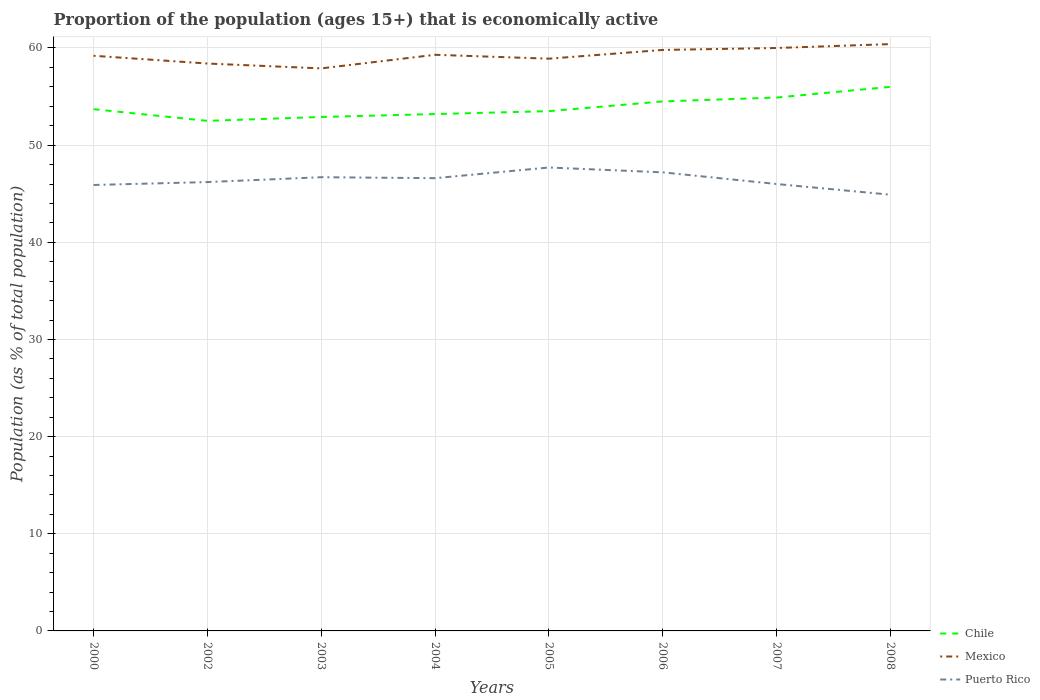How many different coloured lines are there?
Provide a succinct answer. 3. Across all years, what is the maximum proportion of the population that is economically active in Puerto Rico?
Make the answer very short. 44.9. What is the total proportion of the population that is economically active in Puerto Rico in the graph?
Ensure brevity in your answer.  0.6. What is the difference between the highest and the second highest proportion of the population that is economically active in Puerto Rico?
Make the answer very short. 2.8. What is the difference between the highest and the lowest proportion of the population that is economically active in Mexico?
Give a very brief answer. 4. Is the proportion of the population that is economically active in Mexico strictly greater than the proportion of the population that is economically active in Chile over the years?
Offer a terse response. No. How many years are there in the graph?
Your answer should be compact. 8. Does the graph contain any zero values?
Give a very brief answer. No. Does the graph contain grids?
Your response must be concise. Yes. How are the legend labels stacked?
Keep it short and to the point. Vertical. What is the title of the graph?
Ensure brevity in your answer.  Proportion of the population (ages 15+) that is economically active. Does "Niger" appear as one of the legend labels in the graph?
Your answer should be very brief. No. What is the label or title of the X-axis?
Offer a terse response. Years. What is the label or title of the Y-axis?
Make the answer very short. Population (as % of total population). What is the Population (as % of total population) of Chile in 2000?
Keep it short and to the point. 53.7. What is the Population (as % of total population) of Mexico in 2000?
Give a very brief answer. 59.2. What is the Population (as % of total population) of Puerto Rico in 2000?
Give a very brief answer. 45.9. What is the Population (as % of total population) of Chile in 2002?
Your answer should be compact. 52.5. What is the Population (as % of total population) in Mexico in 2002?
Ensure brevity in your answer.  58.4. What is the Population (as % of total population) in Puerto Rico in 2002?
Offer a terse response. 46.2. What is the Population (as % of total population) of Chile in 2003?
Your response must be concise. 52.9. What is the Population (as % of total population) of Mexico in 2003?
Keep it short and to the point. 57.9. What is the Population (as % of total population) in Puerto Rico in 2003?
Provide a succinct answer. 46.7. What is the Population (as % of total population) in Chile in 2004?
Keep it short and to the point. 53.2. What is the Population (as % of total population) of Mexico in 2004?
Your response must be concise. 59.3. What is the Population (as % of total population) of Puerto Rico in 2004?
Offer a terse response. 46.6. What is the Population (as % of total population) of Chile in 2005?
Your answer should be compact. 53.5. What is the Population (as % of total population) of Mexico in 2005?
Keep it short and to the point. 58.9. What is the Population (as % of total population) of Puerto Rico in 2005?
Keep it short and to the point. 47.7. What is the Population (as % of total population) in Chile in 2006?
Provide a succinct answer. 54.5. What is the Population (as % of total population) in Mexico in 2006?
Your response must be concise. 59.8. What is the Population (as % of total population) in Puerto Rico in 2006?
Your response must be concise. 47.2. What is the Population (as % of total population) in Chile in 2007?
Provide a succinct answer. 54.9. What is the Population (as % of total population) in Puerto Rico in 2007?
Give a very brief answer. 46. What is the Population (as % of total population) in Mexico in 2008?
Give a very brief answer. 60.4. What is the Population (as % of total population) of Puerto Rico in 2008?
Provide a short and direct response. 44.9. Across all years, what is the maximum Population (as % of total population) of Mexico?
Give a very brief answer. 60.4. Across all years, what is the maximum Population (as % of total population) of Puerto Rico?
Your answer should be compact. 47.7. Across all years, what is the minimum Population (as % of total population) in Chile?
Your response must be concise. 52.5. Across all years, what is the minimum Population (as % of total population) in Mexico?
Make the answer very short. 57.9. Across all years, what is the minimum Population (as % of total population) in Puerto Rico?
Ensure brevity in your answer.  44.9. What is the total Population (as % of total population) in Chile in the graph?
Ensure brevity in your answer.  431.2. What is the total Population (as % of total population) of Mexico in the graph?
Provide a short and direct response. 473.9. What is the total Population (as % of total population) in Puerto Rico in the graph?
Your answer should be compact. 371.2. What is the difference between the Population (as % of total population) of Chile in 2000 and that in 2003?
Ensure brevity in your answer.  0.8. What is the difference between the Population (as % of total population) in Mexico in 2000 and that in 2003?
Keep it short and to the point. 1.3. What is the difference between the Population (as % of total population) of Puerto Rico in 2000 and that in 2003?
Your answer should be compact. -0.8. What is the difference between the Population (as % of total population) of Puerto Rico in 2000 and that in 2004?
Offer a terse response. -0.7. What is the difference between the Population (as % of total population) of Mexico in 2000 and that in 2005?
Offer a terse response. 0.3. What is the difference between the Population (as % of total population) of Mexico in 2000 and that in 2006?
Make the answer very short. -0.6. What is the difference between the Population (as % of total population) of Puerto Rico in 2000 and that in 2006?
Ensure brevity in your answer.  -1.3. What is the difference between the Population (as % of total population) of Mexico in 2000 and that in 2007?
Offer a very short reply. -0.8. What is the difference between the Population (as % of total population) in Puerto Rico in 2000 and that in 2007?
Keep it short and to the point. -0.1. What is the difference between the Population (as % of total population) of Mexico in 2000 and that in 2008?
Provide a short and direct response. -1.2. What is the difference between the Population (as % of total population) in Mexico in 2002 and that in 2003?
Provide a short and direct response. 0.5. What is the difference between the Population (as % of total population) in Puerto Rico in 2002 and that in 2004?
Make the answer very short. -0.4. What is the difference between the Population (as % of total population) in Puerto Rico in 2002 and that in 2006?
Offer a very short reply. -1. What is the difference between the Population (as % of total population) of Chile in 2002 and that in 2007?
Offer a very short reply. -2.4. What is the difference between the Population (as % of total population) in Mexico in 2002 and that in 2007?
Ensure brevity in your answer.  -1.6. What is the difference between the Population (as % of total population) in Puerto Rico in 2002 and that in 2007?
Ensure brevity in your answer.  0.2. What is the difference between the Population (as % of total population) of Mexico in 2002 and that in 2008?
Your answer should be very brief. -2. What is the difference between the Population (as % of total population) in Puerto Rico in 2002 and that in 2008?
Give a very brief answer. 1.3. What is the difference between the Population (as % of total population) of Mexico in 2003 and that in 2004?
Give a very brief answer. -1.4. What is the difference between the Population (as % of total population) of Puerto Rico in 2003 and that in 2004?
Your answer should be compact. 0.1. What is the difference between the Population (as % of total population) in Mexico in 2003 and that in 2005?
Your answer should be very brief. -1. What is the difference between the Population (as % of total population) of Mexico in 2003 and that in 2006?
Provide a short and direct response. -1.9. What is the difference between the Population (as % of total population) in Chile in 2003 and that in 2007?
Offer a terse response. -2. What is the difference between the Population (as % of total population) of Puerto Rico in 2003 and that in 2007?
Provide a succinct answer. 0.7. What is the difference between the Population (as % of total population) of Chile in 2003 and that in 2008?
Provide a short and direct response. -3.1. What is the difference between the Population (as % of total population) in Puerto Rico in 2003 and that in 2008?
Your answer should be compact. 1.8. What is the difference between the Population (as % of total population) in Mexico in 2004 and that in 2006?
Ensure brevity in your answer.  -0.5. What is the difference between the Population (as % of total population) of Mexico in 2004 and that in 2007?
Your response must be concise. -0.7. What is the difference between the Population (as % of total population) of Puerto Rico in 2004 and that in 2007?
Your answer should be compact. 0.6. What is the difference between the Population (as % of total population) of Chile in 2004 and that in 2008?
Offer a very short reply. -2.8. What is the difference between the Population (as % of total population) in Mexico in 2004 and that in 2008?
Keep it short and to the point. -1.1. What is the difference between the Population (as % of total population) in Chile in 2005 and that in 2006?
Your answer should be compact. -1. What is the difference between the Population (as % of total population) of Mexico in 2005 and that in 2006?
Your response must be concise. -0.9. What is the difference between the Population (as % of total population) of Puerto Rico in 2005 and that in 2006?
Ensure brevity in your answer.  0.5. What is the difference between the Population (as % of total population) in Mexico in 2005 and that in 2007?
Offer a very short reply. -1.1. What is the difference between the Population (as % of total population) of Chile in 2005 and that in 2008?
Make the answer very short. -2.5. What is the difference between the Population (as % of total population) of Mexico in 2005 and that in 2008?
Keep it short and to the point. -1.5. What is the difference between the Population (as % of total population) of Puerto Rico in 2006 and that in 2007?
Offer a very short reply. 1.2. What is the difference between the Population (as % of total population) of Puerto Rico in 2006 and that in 2008?
Your answer should be compact. 2.3. What is the difference between the Population (as % of total population) of Chile in 2007 and that in 2008?
Your answer should be compact. -1.1. What is the difference between the Population (as % of total population) in Chile in 2000 and the Population (as % of total population) in Puerto Rico in 2003?
Make the answer very short. 7. What is the difference between the Population (as % of total population) of Chile in 2000 and the Population (as % of total population) of Puerto Rico in 2004?
Your answer should be very brief. 7.1. What is the difference between the Population (as % of total population) in Mexico in 2000 and the Population (as % of total population) in Puerto Rico in 2004?
Make the answer very short. 12.6. What is the difference between the Population (as % of total population) in Mexico in 2000 and the Population (as % of total population) in Puerto Rico in 2005?
Provide a short and direct response. 11.5. What is the difference between the Population (as % of total population) in Chile in 2000 and the Population (as % of total population) in Puerto Rico in 2006?
Keep it short and to the point. 6.5. What is the difference between the Population (as % of total population) in Mexico in 2000 and the Population (as % of total population) in Puerto Rico in 2006?
Keep it short and to the point. 12. What is the difference between the Population (as % of total population) in Chile in 2000 and the Population (as % of total population) in Puerto Rico in 2007?
Your answer should be compact. 7.7. What is the difference between the Population (as % of total population) of Mexico in 2000 and the Population (as % of total population) of Puerto Rico in 2007?
Your answer should be very brief. 13.2. What is the difference between the Population (as % of total population) in Chile in 2000 and the Population (as % of total population) in Puerto Rico in 2008?
Offer a terse response. 8.8. What is the difference between the Population (as % of total population) in Chile in 2002 and the Population (as % of total population) in Mexico in 2003?
Give a very brief answer. -5.4. What is the difference between the Population (as % of total population) in Chile in 2002 and the Population (as % of total population) in Puerto Rico in 2003?
Provide a short and direct response. 5.8. What is the difference between the Population (as % of total population) in Chile in 2002 and the Population (as % of total population) in Mexico in 2004?
Provide a short and direct response. -6.8. What is the difference between the Population (as % of total population) in Mexico in 2002 and the Population (as % of total population) in Puerto Rico in 2004?
Your answer should be very brief. 11.8. What is the difference between the Population (as % of total population) in Chile in 2002 and the Population (as % of total population) in Puerto Rico in 2005?
Ensure brevity in your answer.  4.8. What is the difference between the Population (as % of total population) in Chile in 2002 and the Population (as % of total population) in Mexico in 2006?
Provide a succinct answer. -7.3. What is the difference between the Population (as % of total population) in Chile in 2002 and the Population (as % of total population) in Puerto Rico in 2006?
Give a very brief answer. 5.3. What is the difference between the Population (as % of total population) in Chile in 2002 and the Population (as % of total population) in Mexico in 2007?
Your response must be concise. -7.5. What is the difference between the Population (as % of total population) in Chile in 2002 and the Population (as % of total population) in Puerto Rico in 2007?
Keep it short and to the point. 6.5. What is the difference between the Population (as % of total population) in Chile in 2002 and the Population (as % of total population) in Puerto Rico in 2008?
Make the answer very short. 7.6. What is the difference between the Population (as % of total population) in Chile in 2003 and the Population (as % of total population) in Mexico in 2004?
Provide a succinct answer. -6.4. What is the difference between the Population (as % of total population) in Chile in 2003 and the Population (as % of total population) in Mexico in 2005?
Offer a terse response. -6. What is the difference between the Population (as % of total population) in Chile in 2003 and the Population (as % of total population) in Mexico in 2006?
Make the answer very short. -6.9. What is the difference between the Population (as % of total population) of Chile in 2003 and the Population (as % of total population) of Puerto Rico in 2006?
Keep it short and to the point. 5.7. What is the difference between the Population (as % of total population) of Chile in 2003 and the Population (as % of total population) of Puerto Rico in 2007?
Keep it short and to the point. 6.9. What is the difference between the Population (as % of total population) of Chile in 2003 and the Population (as % of total population) of Mexico in 2008?
Your answer should be very brief. -7.5. What is the difference between the Population (as % of total population) of Chile in 2003 and the Population (as % of total population) of Puerto Rico in 2008?
Your answer should be very brief. 8. What is the difference between the Population (as % of total population) of Mexico in 2003 and the Population (as % of total population) of Puerto Rico in 2008?
Make the answer very short. 13. What is the difference between the Population (as % of total population) of Chile in 2004 and the Population (as % of total population) of Puerto Rico in 2005?
Make the answer very short. 5.5. What is the difference between the Population (as % of total population) of Chile in 2004 and the Population (as % of total population) of Mexico in 2006?
Make the answer very short. -6.6. What is the difference between the Population (as % of total population) of Chile in 2004 and the Population (as % of total population) of Puerto Rico in 2006?
Give a very brief answer. 6. What is the difference between the Population (as % of total population) in Chile in 2004 and the Population (as % of total population) in Mexico in 2007?
Your answer should be compact. -6.8. What is the difference between the Population (as % of total population) of Chile in 2004 and the Population (as % of total population) of Puerto Rico in 2007?
Your response must be concise. 7.2. What is the difference between the Population (as % of total population) in Mexico in 2004 and the Population (as % of total population) in Puerto Rico in 2007?
Your answer should be compact. 13.3. What is the difference between the Population (as % of total population) in Chile in 2004 and the Population (as % of total population) in Mexico in 2008?
Your answer should be compact. -7.2. What is the difference between the Population (as % of total population) of Chile in 2005 and the Population (as % of total population) of Puerto Rico in 2006?
Ensure brevity in your answer.  6.3. What is the difference between the Population (as % of total population) of Chile in 2005 and the Population (as % of total population) of Mexico in 2007?
Offer a terse response. -6.5. What is the difference between the Population (as % of total population) in Chile in 2005 and the Population (as % of total population) in Puerto Rico in 2007?
Your response must be concise. 7.5. What is the difference between the Population (as % of total population) of Chile in 2005 and the Population (as % of total population) of Mexico in 2008?
Give a very brief answer. -6.9. What is the difference between the Population (as % of total population) in Chile in 2005 and the Population (as % of total population) in Puerto Rico in 2008?
Your answer should be very brief. 8.6. What is the difference between the Population (as % of total population) of Chile in 2006 and the Population (as % of total population) of Mexico in 2007?
Keep it short and to the point. -5.5. What is the difference between the Population (as % of total population) in Mexico in 2006 and the Population (as % of total population) in Puerto Rico in 2008?
Your response must be concise. 14.9. What is the difference between the Population (as % of total population) in Chile in 2007 and the Population (as % of total population) in Puerto Rico in 2008?
Your answer should be very brief. 10. What is the difference between the Population (as % of total population) of Mexico in 2007 and the Population (as % of total population) of Puerto Rico in 2008?
Your answer should be very brief. 15.1. What is the average Population (as % of total population) of Chile per year?
Ensure brevity in your answer.  53.9. What is the average Population (as % of total population) of Mexico per year?
Offer a terse response. 59.24. What is the average Population (as % of total population) in Puerto Rico per year?
Offer a very short reply. 46.4. In the year 2000, what is the difference between the Population (as % of total population) in Chile and Population (as % of total population) in Mexico?
Your answer should be compact. -5.5. In the year 2000, what is the difference between the Population (as % of total population) in Chile and Population (as % of total population) in Puerto Rico?
Ensure brevity in your answer.  7.8. In the year 2002, what is the difference between the Population (as % of total population) in Mexico and Population (as % of total population) in Puerto Rico?
Ensure brevity in your answer.  12.2. In the year 2003, what is the difference between the Population (as % of total population) in Chile and Population (as % of total population) in Puerto Rico?
Provide a succinct answer. 6.2. In the year 2003, what is the difference between the Population (as % of total population) of Mexico and Population (as % of total population) of Puerto Rico?
Offer a very short reply. 11.2. In the year 2004, what is the difference between the Population (as % of total population) of Chile and Population (as % of total population) of Puerto Rico?
Make the answer very short. 6.6. In the year 2004, what is the difference between the Population (as % of total population) of Mexico and Population (as % of total population) of Puerto Rico?
Keep it short and to the point. 12.7. In the year 2005, what is the difference between the Population (as % of total population) in Mexico and Population (as % of total population) in Puerto Rico?
Offer a very short reply. 11.2. In the year 2006, what is the difference between the Population (as % of total population) in Mexico and Population (as % of total population) in Puerto Rico?
Make the answer very short. 12.6. In the year 2007, what is the difference between the Population (as % of total population) in Chile and Population (as % of total population) in Mexico?
Provide a short and direct response. -5.1. In the year 2007, what is the difference between the Population (as % of total population) of Chile and Population (as % of total population) of Puerto Rico?
Provide a short and direct response. 8.9. In the year 2007, what is the difference between the Population (as % of total population) in Mexico and Population (as % of total population) in Puerto Rico?
Keep it short and to the point. 14. In the year 2008, what is the difference between the Population (as % of total population) of Chile and Population (as % of total population) of Puerto Rico?
Provide a succinct answer. 11.1. In the year 2008, what is the difference between the Population (as % of total population) in Mexico and Population (as % of total population) in Puerto Rico?
Provide a short and direct response. 15.5. What is the ratio of the Population (as % of total population) in Chile in 2000 to that in 2002?
Provide a succinct answer. 1.02. What is the ratio of the Population (as % of total population) of Mexico in 2000 to that in 2002?
Make the answer very short. 1.01. What is the ratio of the Population (as % of total population) in Puerto Rico in 2000 to that in 2002?
Ensure brevity in your answer.  0.99. What is the ratio of the Population (as % of total population) of Chile in 2000 to that in 2003?
Give a very brief answer. 1.02. What is the ratio of the Population (as % of total population) in Mexico in 2000 to that in 2003?
Ensure brevity in your answer.  1.02. What is the ratio of the Population (as % of total population) in Puerto Rico in 2000 to that in 2003?
Provide a short and direct response. 0.98. What is the ratio of the Population (as % of total population) in Chile in 2000 to that in 2004?
Your answer should be very brief. 1.01. What is the ratio of the Population (as % of total population) in Mexico in 2000 to that in 2004?
Offer a terse response. 1. What is the ratio of the Population (as % of total population) of Puerto Rico in 2000 to that in 2004?
Give a very brief answer. 0.98. What is the ratio of the Population (as % of total population) of Chile in 2000 to that in 2005?
Your response must be concise. 1. What is the ratio of the Population (as % of total population) in Mexico in 2000 to that in 2005?
Your answer should be very brief. 1.01. What is the ratio of the Population (as % of total population) in Puerto Rico in 2000 to that in 2005?
Keep it short and to the point. 0.96. What is the ratio of the Population (as % of total population) in Mexico in 2000 to that in 2006?
Offer a terse response. 0.99. What is the ratio of the Population (as % of total population) of Puerto Rico in 2000 to that in 2006?
Give a very brief answer. 0.97. What is the ratio of the Population (as % of total population) in Chile in 2000 to that in 2007?
Provide a short and direct response. 0.98. What is the ratio of the Population (as % of total population) in Mexico in 2000 to that in 2007?
Ensure brevity in your answer.  0.99. What is the ratio of the Population (as % of total population) of Puerto Rico in 2000 to that in 2007?
Ensure brevity in your answer.  1. What is the ratio of the Population (as % of total population) of Chile in 2000 to that in 2008?
Keep it short and to the point. 0.96. What is the ratio of the Population (as % of total population) in Mexico in 2000 to that in 2008?
Ensure brevity in your answer.  0.98. What is the ratio of the Population (as % of total population) of Puerto Rico in 2000 to that in 2008?
Ensure brevity in your answer.  1.02. What is the ratio of the Population (as % of total population) in Mexico in 2002 to that in 2003?
Your answer should be very brief. 1.01. What is the ratio of the Population (as % of total population) in Puerto Rico in 2002 to that in 2003?
Keep it short and to the point. 0.99. What is the ratio of the Population (as % of total population) in Puerto Rico in 2002 to that in 2004?
Your answer should be compact. 0.99. What is the ratio of the Population (as % of total population) in Chile in 2002 to that in 2005?
Your response must be concise. 0.98. What is the ratio of the Population (as % of total population) in Puerto Rico in 2002 to that in 2005?
Ensure brevity in your answer.  0.97. What is the ratio of the Population (as % of total population) of Chile in 2002 to that in 2006?
Keep it short and to the point. 0.96. What is the ratio of the Population (as % of total population) of Mexico in 2002 to that in 2006?
Make the answer very short. 0.98. What is the ratio of the Population (as % of total population) in Puerto Rico in 2002 to that in 2006?
Ensure brevity in your answer.  0.98. What is the ratio of the Population (as % of total population) in Chile in 2002 to that in 2007?
Make the answer very short. 0.96. What is the ratio of the Population (as % of total population) of Mexico in 2002 to that in 2007?
Your answer should be compact. 0.97. What is the ratio of the Population (as % of total population) in Puerto Rico in 2002 to that in 2007?
Give a very brief answer. 1. What is the ratio of the Population (as % of total population) of Mexico in 2002 to that in 2008?
Provide a succinct answer. 0.97. What is the ratio of the Population (as % of total population) of Chile in 2003 to that in 2004?
Provide a short and direct response. 0.99. What is the ratio of the Population (as % of total population) in Mexico in 2003 to that in 2004?
Offer a terse response. 0.98. What is the ratio of the Population (as % of total population) in Puerto Rico in 2003 to that in 2005?
Your answer should be very brief. 0.98. What is the ratio of the Population (as % of total population) in Chile in 2003 to that in 2006?
Make the answer very short. 0.97. What is the ratio of the Population (as % of total population) in Mexico in 2003 to that in 2006?
Make the answer very short. 0.97. What is the ratio of the Population (as % of total population) in Chile in 2003 to that in 2007?
Your answer should be very brief. 0.96. What is the ratio of the Population (as % of total population) in Mexico in 2003 to that in 2007?
Your answer should be very brief. 0.96. What is the ratio of the Population (as % of total population) of Puerto Rico in 2003 to that in 2007?
Give a very brief answer. 1.02. What is the ratio of the Population (as % of total population) of Chile in 2003 to that in 2008?
Give a very brief answer. 0.94. What is the ratio of the Population (as % of total population) in Mexico in 2003 to that in 2008?
Ensure brevity in your answer.  0.96. What is the ratio of the Population (as % of total population) of Puerto Rico in 2003 to that in 2008?
Make the answer very short. 1.04. What is the ratio of the Population (as % of total population) of Chile in 2004 to that in 2005?
Your answer should be very brief. 0.99. What is the ratio of the Population (as % of total population) of Mexico in 2004 to that in 2005?
Offer a very short reply. 1.01. What is the ratio of the Population (as % of total population) in Puerto Rico in 2004 to that in 2005?
Your response must be concise. 0.98. What is the ratio of the Population (as % of total population) of Chile in 2004 to that in 2006?
Make the answer very short. 0.98. What is the ratio of the Population (as % of total population) of Puerto Rico in 2004 to that in 2006?
Ensure brevity in your answer.  0.99. What is the ratio of the Population (as % of total population) of Mexico in 2004 to that in 2007?
Give a very brief answer. 0.99. What is the ratio of the Population (as % of total population) of Puerto Rico in 2004 to that in 2007?
Your answer should be compact. 1.01. What is the ratio of the Population (as % of total population) of Chile in 2004 to that in 2008?
Give a very brief answer. 0.95. What is the ratio of the Population (as % of total population) in Mexico in 2004 to that in 2008?
Provide a succinct answer. 0.98. What is the ratio of the Population (as % of total population) of Puerto Rico in 2004 to that in 2008?
Provide a short and direct response. 1.04. What is the ratio of the Population (as % of total population) in Chile in 2005 to that in 2006?
Give a very brief answer. 0.98. What is the ratio of the Population (as % of total population) of Mexico in 2005 to that in 2006?
Give a very brief answer. 0.98. What is the ratio of the Population (as % of total population) of Puerto Rico in 2005 to that in 2006?
Ensure brevity in your answer.  1.01. What is the ratio of the Population (as % of total population) of Chile in 2005 to that in 2007?
Provide a short and direct response. 0.97. What is the ratio of the Population (as % of total population) in Mexico in 2005 to that in 2007?
Ensure brevity in your answer.  0.98. What is the ratio of the Population (as % of total population) of Chile in 2005 to that in 2008?
Offer a very short reply. 0.96. What is the ratio of the Population (as % of total population) in Mexico in 2005 to that in 2008?
Your answer should be compact. 0.98. What is the ratio of the Population (as % of total population) of Puerto Rico in 2005 to that in 2008?
Ensure brevity in your answer.  1.06. What is the ratio of the Population (as % of total population) in Chile in 2006 to that in 2007?
Offer a terse response. 0.99. What is the ratio of the Population (as % of total population) in Puerto Rico in 2006 to that in 2007?
Your answer should be compact. 1.03. What is the ratio of the Population (as % of total population) in Chile in 2006 to that in 2008?
Ensure brevity in your answer.  0.97. What is the ratio of the Population (as % of total population) of Mexico in 2006 to that in 2008?
Your response must be concise. 0.99. What is the ratio of the Population (as % of total population) in Puerto Rico in 2006 to that in 2008?
Keep it short and to the point. 1.05. What is the ratio of the Population (as % of total population) in Chile in 2007 to that in 2008?
Give a very brief answer. 0.98. What is the ratio of the Population (as % of total population) in Puerto Rico in 2007 to that in 2008?
Provide a short and direct response. 1.02. What is the difference between the highest and the second highest Population (as % of total population) in Mexico?
Your answer should be very brief. 0.4. What is the difference between the highest and the second highest Population (as % of total population) in Puerto Rico?
Offer a very short reply. 0.5. What is the difference between the highest and the lowest Population (as % of total population) in Chile?
Provide a succinct answer. 3.5. What is the difference between the highest and the lowest Population (as % of total population) of Mexico?
Your answer should be compact. 2.5. What is the difference between the highest and the lowest Population (as % of total population) of Puerto Rico?
Keep it short and to the point. 2.8. 